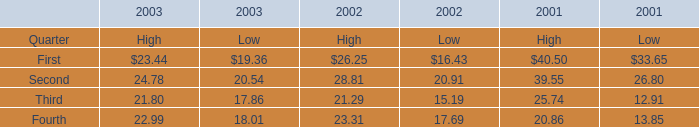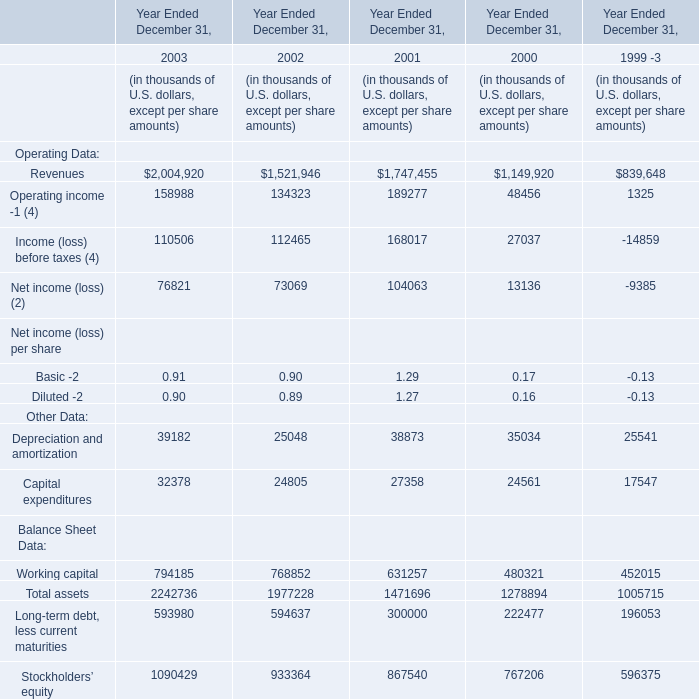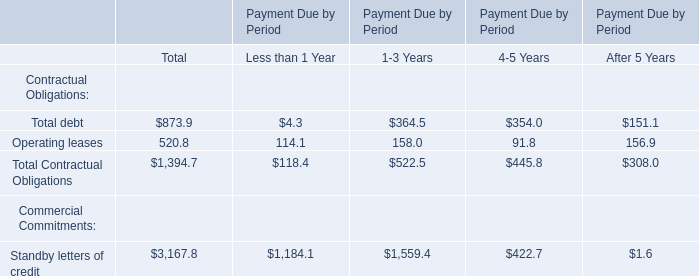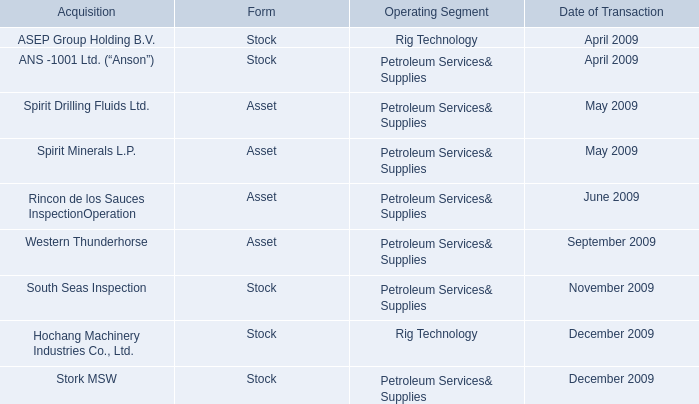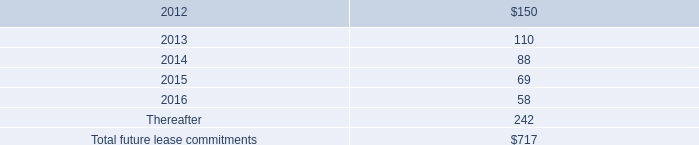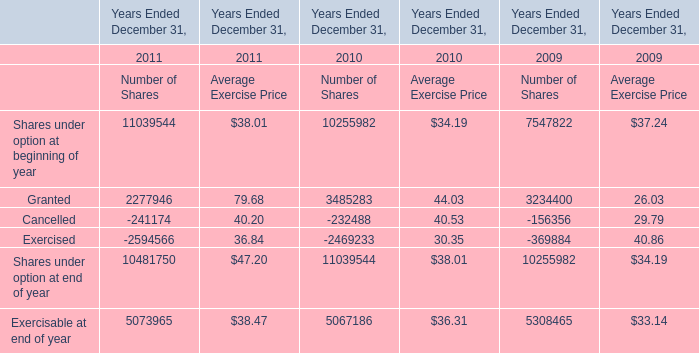What was the total amount of elements for High in 2003 ? 
Computations: (((23.44 + 24.78) + 21.8) + 22.99)
Answer: 93.01. 